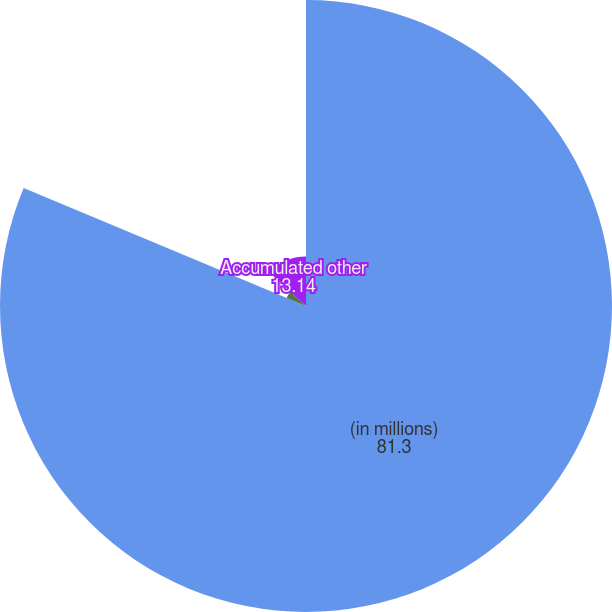Convert chart. <chart><loc_0><loc_0><loc_500><loc_500><pie_chart><fcel>(in millions)<fcel>Net gain/(loss)<fcel>Accumulated other<nl><fcel>81.3%<fcel>5.56%<fcel>13.14%<nl></chart> 